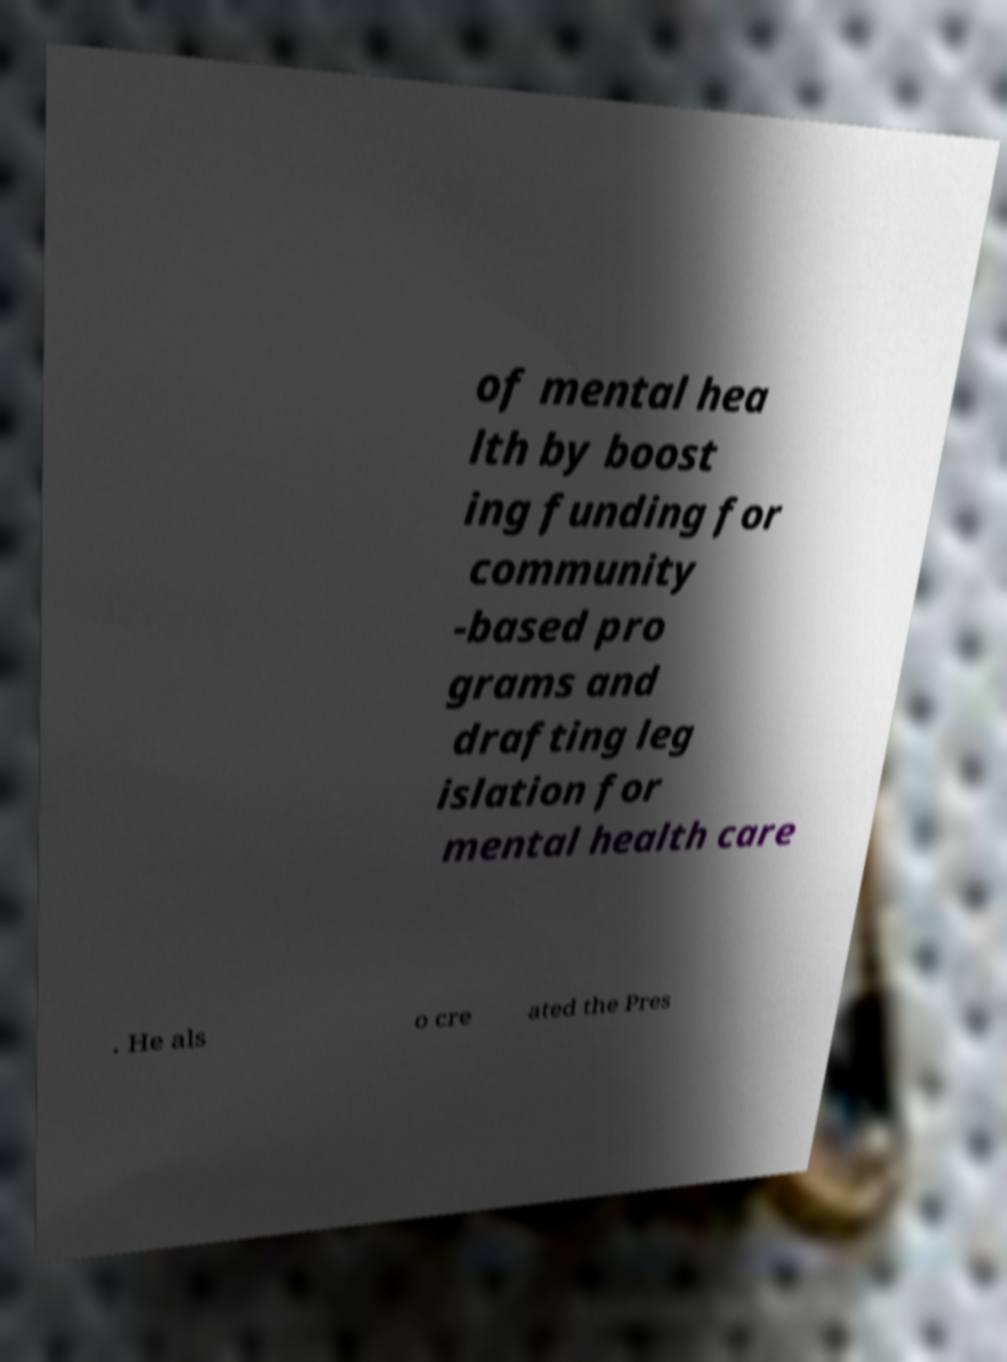Please identify and transcribe the text found in this image. of mental hea lth by boost ing funding for community -based pro grams and drafting leg islation for mental health care . He als o cre ated the Pres 